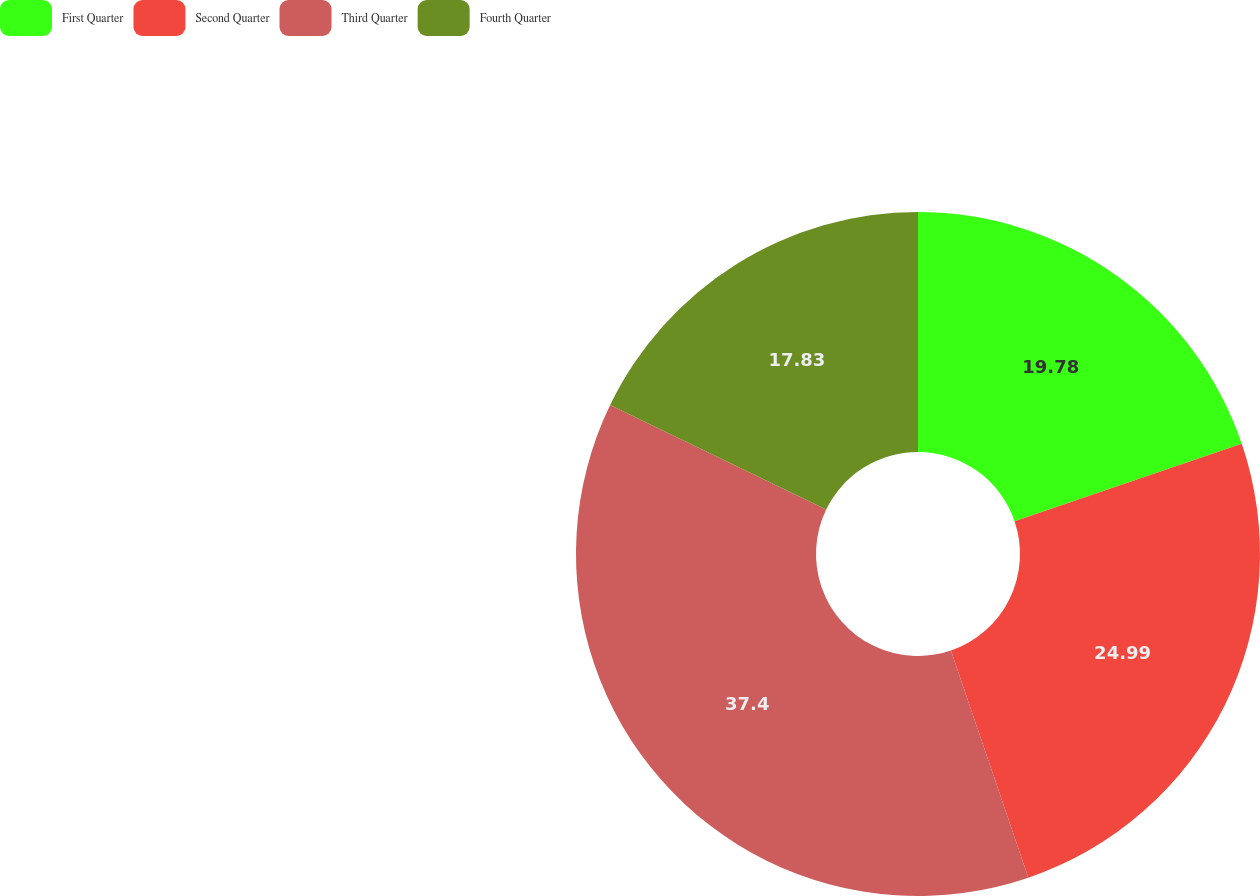Convert chart. <chart><loc_0><loc_0><loc_500><loc_500><pie_chart><fcel>First Quarter<fcel>Second Quarter<fcel>Third Quarter<fcel>Fourth Quarter<nl><fcel>19.78%<fcel>24.99%<fcel>37.4%<fcel>17.83%<nl></chart> 